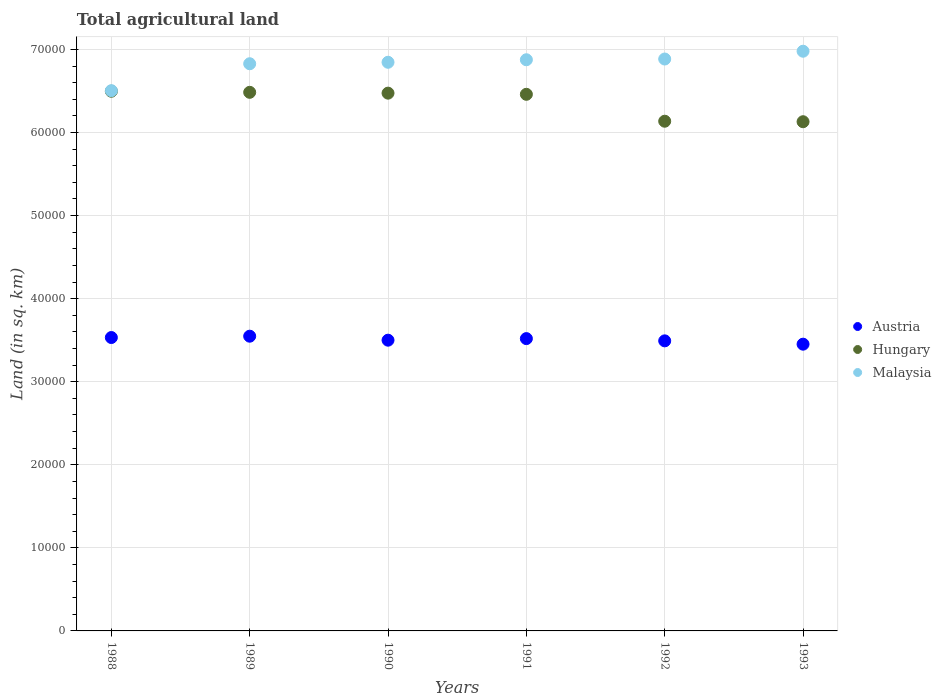How many different coloured dotlines are there?
Offer a very short reply. 3. What is the total agricultural land in Malaysia in 1992?
Offer a very short reply. 6.88e+04. Across all years, what is the maximum total agricultural land in Malaysia?
Offer a very short reply. 6.98e+04. Across all years, what is the minimum total agricultural land in Hungary?
Ensure brevity in your answer.  6.13e+04. In which year was the total agricultural land in Austria maximum?
Your answer should be very brief. 1989. In which year was the total agricultural land in Austria minimum?
Offer a terse response. 1993. What is the total total agricultural land in Malaysia in the graph?
Offer a terse response. 4.09e+05. What is the difference between the total agricultural land in Hungary in 1991 and that in 1992?
Give a very brief answer. 3240. What is the difference between the total agricultural land in Austria in 1989 and the total agricultural land in Malaysia in 1990?
Offer a very short reply. -3.30e+04. What is the average total agricultural land in Malaysia per year?
Ensure brevity in your answer.  6.82e+04. In the year 1989, what is the difference between the total agricultural land in Malaysia and total agricultural land in Hungary?
Give a very brief answer. 3440. In how many years, is the total agricultural land in Austria greater than 36000 sq.km?
Make the answer very short. 0. What is the ratio of the total agricultural land in Malaysia in 1990 to that in 1992?
Make the answer very short. 0.99. Is the total agricultural land in Hungary in 1989 less than that in 1991?
Provide a short and direct response. No. What is the difference between the highest and the second highest total agricultural land in Hungary?
Your answer should be compact. 130. What is the difference between the highest and the lowest total agricultural land in Malaysia?
Your answer should be very brief. 4748. In how many years, is the total agricultural land in Hungary greater than the average total agricultural land in Hungary taken over all years?
Your answer should be compact. 4. Is the sum of the total agricultural land in Austria in 1989 and 1992 greater than the maximum total agricultural land in Malaysia across all years?
Provide a succinct answer. Yes. Is it the case that in every year, the sum of the total agricultural land in Hungary and total agricultural land in Austria  is greater than the total agricultural land in Malaysia?
Your answer should be compact. Yes. Is the total agricultural land in Austria strictly greater than the total agricultural land in Hungary over the years?
Your response must be concise. No. Is the total agricultural land in Austria strictly less than the total agricultural land in Malaysia over the years?
Give a very brief answer. Yes. How many years are there in the graph?
Your answer should be very brief. 6. What is the difference between two consecutive major ticks on the Y-axis?
Offer a very short reply. 10000. Where does the legend appear in the graph?
Provide a succinct answer. Center right. What is the title of the graph?
Make the answer very short. Total agricultural land. What is the label or title of the X-axis?
Your response must be concise. Years. What is the label or title of the Y-axis?
Give a very brief answer. Land (in sq. km). What is the Land (in sq. km) of Austria in 1988?
Ensure brevity in your answer.  3.53e+04. What is the Land (in sq. km) in Hungary in 1988?
Make the answer very short. 6.50e+04. What is the Land (in sq. km) of Malaysia in 1988?
Make the answer very short. 6.50e+04. What is the Land (in sq. km) of Austria in 1989?
Your answer should be very brief. 3.55e+04. What is the Land (in sq. km) of Hungary in 1989?
Your answer should be very brief. 6.48e+04. What is the Land (in sq. km) in Malaysia in 1989?
Offer a terse response. 6.83e+04. What is the Land (in sq. km) in Austria in 1990?
Make the answer very short. 3.50e+04. What is the Land (in sq. km) of Hungary in 1990?
Offer a very short reply. 6.47e+04. What is the Land (in sq. km) of Malaysia in 1990?
Provide a short and direct response. 6.85e+04. What is the Land (in sq. km) of Austria in 1991?
Ensure brevity in your answer.  3.52e+04. What is the Land (in sq. km) in Hungary in 1991?
Your answer should be very brief. 6.46e+04. What is the Land (in sq. km) of Malaysia in 1991?
Give a very brief answer. 6.88e+04. What is the Land (in sq. km) of Austria in 1992?
Provide a succinct answer. 3.49e+04. What is the Land (in sq. km) of Hungary in 1992?
Give a very brief answer. 6.14e+04. What is the Land (in sq. km) in Malaysia in 1992?
Offer a terse response. 6.88e+04. What is the Land (in sq. km) of Austria in 1993?
Your answer should be compact. 3.45e+04. What is the Land (in sq. km) in Hungary in 1993?
Make the answer very short. 6.13e+04. What is the Land (in sq. km) in Malaysia in 1993?
Keep it short and to the point. 6.98e+04. Across all years, what is the maximum Land (in sq. km) in Austria?
Offer a very short reply. 3.55e+04. Across all years, what is the maximum Land (in sq. km) in Hungary?
Offer a very short reply. 6.50e+04. Across all years, what is the maximum Land (in sq. km) in Malaysia?
Your response must be concise. 6.98e+04. Across all years, what is the minimum Land (in sq. km) of Austria?
Your response must be concise. 3.45e+04. Across all years, what is the minimum Land (in sq. km) of Hungary?
Offer a terse response. 6.13e+04. Across all years, what is the minimum Land (in sq. km) in Malaysia?
Keep it short and to the point. 6.50e+04. What is the total Land (in sq. km) in Austria in the graph?
Provide a short and direct response. 2.10e+05. What is the total Land (in sq. km) in Hungary in the graph?
Keep it short and to the point. 3.82e+05. What is the total Land (in sq. km) of Malaysia in the graph?
Keep it short and to the point. 4.09e+05. What is the difference between the Land (in sq. km) in Austria in 1988 and that in 1989?
Your response must be concise. -160. What is the difference between the Land (in sq. km) of Hungary in 1988 and that in 1989?
Your answer should be compact. 130. What is the difference between the Land (in sq. km) in Malaysia in 1988 and that in 1989?
Your answer should be compact. -3241. What is the difference between the Land (in sq. km) in Austria in 1988 and that in 1990?
Offer a very short reply. 320. What is the difference between the Land (in sq. km) of Hungary in 1988 and that in 1990?
Offer a terse response. 230. What is the difference between the Land (in sq. km) in Malaysia in 1988 and that in 1990?
Provide a succinct answer. -3418. What is the difference between the Land (in sq. km) of Austria in 1988 and that in 1991?
Offer a terse response. 130. What is the difference between the Land (in sq. km) in Hungary in 1988 and that in 1991?
Keep it short and to the point. 370. What is the difference between the Land (in sq. km) in Malaysia in 1988 and that in 1991?
Offer a terse response. -3721. What is the difference between the Land (in sq. km) of Hungary in 1988 and that in 1992?
Make the answer very short. 3610. What is the difference between the Land (in sq. km) of Malaysia in 1988 and that in 1992?
Ensure brevity in your answer.  -3809. What is the difference between the Land (in sq. km) in Austria in 1988 and that in 1993?
Offer a very short reply. 800. What is the difference between the Land (in sq. km) of Hungary in 1988 and that in 1993?
Provide a short and direct response. 3670. What is the difference between the Land (in sq. km) of Malaysia in 1988 and that in 1993?
Your response must be concise. -4748. What is the difference between the Land (in sq. km) of Austria in 1989 and that in 1990?
Keep it short and to the point. 480. What is the difference between the Land (in sq. km) of Malaysia in 1989 and that in 1990?
Offer a terse response. -177. What is the difference between the Land (in sq. km) of Austria in 1989 and that in 1991?
Your response must be concise. 290. What is the difference between the Land (in sq. km) in Hungary in 1989 and that in 1991?
Give a very brief answer. 240. What is the difference between the Land (in sq. km) in Malaysia in 1989 and that in 1991?
Your answer should be compact. -480. What is the difference between the Land (in sq. km) of Austria in 1989 and that in 1992?
Provide a short and direct response. 560. What is the difference between the Land (in sq. km) in Hungary in 1989 and that in 1992?
Make the answer very short. 3480. What is the difference between the Land (in sq. km) of Malaysia in 1989 and that in 1992?
Your answer should be very brief. -568. What is the difference between the Land (in sq. km) of Austria in 1989 and that in 1993?
Keep it short and to the point. 960. What is the difference between the Land (in sq. km) of Hungary in 1989 and that in 1993?
Your answer should be compact. 3540. What is the difference between the Land (in sq. km) in Malaysia in 1989 and that in 1993?
Your response must be concise. -1507. What is the difference between the Land (in sq. km) of Austria in 1990 and that in 1991?
Offer a terse response. -190. What is the difference between the Land (in sq. km) of Hungary in 1990 and that in 1991?
Offer a terse response. 140. What is the difference between the Land (in sq. km) of Malaysia in 1990 and that in 1991?
Provide a short and direct response. -303. What is the difference between the Land (in sq. km) of Hungary in 1990 and that in 1992?
Your answer should be compact. 3380. What is the difference between the Land (in sq. km) in Malaysia in 1990 and that in 1992?
Keep it short and to the point. -391. What is the difference between the Land (in sq. km) in Austria in 1990 and that in 1993?
Your answer should be compact. 480. What is the difference between the Land (in sq. km) of Hungary in 1990 and that in 1993?
Give a very brief answer. 3440. What is the difference between the Land (in sq. km) in Malaysia in 1990 and that in 1993?
Provide a short and direct response. -1330. What is the difference between the Land (in sq. km) of Austria in 1991 and that in 1992?
Provide a succinct answer. 270. What is the difference between the Land (in sq. km) of Hungary in 1991 and that in 1992?
Your response must be concise. 3240. What is the difference between the Land (in sq. km) of Malaysia in 1991 and that in 1992?
Make the answer very short. -88. What is the difference between the Land (in sq. km) in Austria in 1991 and that in 1993?
Offer a very short reply. 670. What is the difference between the Land (in sq. km) of Hungary in 1991 and that in 1993?
Offer a very short reply. 3300. What is the difference between the Land (in sq. km) of Malaysia in 1991 and that in 1993?
Offer a very short reply. -1027. What is the difference between the Land (in sq. km) in Austria in 1992 and that in 1993?
Keep it short and to the point. 400. What is the difference between the Land (in sq. km) in Malaysia in 1992 and that in 1993?
Give a very brief answer. -939. What is the difference between the Land (in sq. km) of Austria in 1988 and the Land (in sq. km) of Hungary in 1989?
Ensure brevity in your answer.  -2.95e+04. What is the difference between the Land (in sq. km) of Austria in 1988 and the Land (in sq. km) of Malaysia in 1989?
Your answer should be compact. -3.30e+04. What is the difference between the Land (in sq. km) in Hungary in 1988 and the Land (in sq. km) in Malaysia in 1989?
Your answer should be compact. -3310. What is the difference between the Land (in sq. km) in Austria in 1988 and the Land (in sq. km) in Hungary in 1990?
Provide a short and direct response. -2.94e+04. What is the difference between the Land (in sq. km) of Austria in 1988 and the Land (in sq. km) of Malaysia in 1990?
Keep it short and to the point. -3.31e+04. What is the difference between the Land (in sq. km) of Hungary in 1988 and the Land (in sq. km) of Malaysia in 1990?
Keep it short and to the point. -3487. What is the difference between the Land (in sq. km) of Austria in 1988 and the Land (in sq. km) of Hungary in 1991?
Keep it short and to the point. -2.93e+04. What is the difference between the Land (in sq. km) in Austria in 1988 and the Land (in sq. km) in Malaysia in 1991?
Offer a terse response. -3.34e+04. What is the difference between the Land (in sq. km) in Hungary in 1988 and the Land (in sq. km) in Malaysia in 1991?
Offer a very short reply. -3790. What is the difference between the Land (in sq. km) of Austria in 1988 and the Land (in sq. km) of Hungary in 1992?
Provide a succinct answer. -2.60e+04. What is the difference between the Land (in sq. km) of Austria in 1988 and the Land (in sq. km) of Malaysia in 1992?
Make the answer very short. -3.35e+04. What is the difference between the Land (in sq. km) in Hungary in 1988 and the Land (in sq. km) in Malaysia in 1992?
Offer a very short reply. -3878. What is the difference between the Land (in sq. km) in Austria in 1988 and the Land (in sq. km) in Hungary in 1993?
Provide a short and direct response. -2.60e+04. What is the difference between the Land (in sq. km) of Austria in 1988 and the Land (in sq. km) of Malaysia in 1993?
Provide a short and direct response. -3.45e+04. What is the difference between the Land (in sq. km) of Hungary in 1988 and the Land (in sq. km) of Malaysia in 1993?
Keep it short and to the point. -4817. What is the difference between the Land (in sq. km) in Austria in 1989 and the Land (in sq. km) in Hungary in 1990?
Your answer should be compact. -2.93e+04. What is the difference between the Land (in sq. km) in Austria in 1989 and the Land (in sq. km) in Malaysia in 1990?
Keep it short and to the point. -3.30e+04. What is the difference between the Land (in sq. km) in Hungary in 1989 and the Land (in sq. km) in Malaysia in 1990?
Ensure brevity in your answer.  -3617. What is the difference between the Land (in sq. km) in Austria in 1989 and the Land (in sq. km) in Hungary in 1991?
Give a very brief answer. -2.91e+04. What is the difference between the Land (in sq. km) in Austria in 1989 and the Land (in sq. km) in Malaysia in 1991?
Ensure brevity in your answer.  -3.33e+04. What is the difference between the Land (in sq. km) of Hungary in 1989 and the Land (in sq. km) of Malaysia in 1991?
Offer a terse response. -3920. What is the difference between the Land (in sq. km) of Austria in 1989 and the Land (in sq. km) of Hungary in 1992?
Your answer should be compact. -2.59e+04. What is the difference between the Land (in sq. km) of Austria in 1989 and the Land (in sq. km) of Malaysia in 1992?
Give a very brief answer. -3.34e+04. What is the difference between the Land (in sq. km) in Hungary in 1989 and the Land (in sq. km) in Malaysia in 1992?
Keep it short and to the point. -4008. What is the difference between the Land (in sq. km) in Austria in 1989 and the Land (in sq. km) in Hungary in 1993?
Your answer should be very brief. -2.58e+04. What is the difference between the Land (in sq. km) of Austria in 1989 and the Land (in sq. km) of Malaysia in 1993?
Ensure brevity in your answer.  -3.43e+04. What is the difference between the Land (in sq. km) in Hungary in 1989 and the Land (in sq. km) in Malaysia in 1993?
Your answer should be very brief. -4947. What is the difference between the Land (in sq. km) of Austria in 1990 and the Land (in sq. km) of Hungary in 1991?
Your response must be concise. -2.96e+04. What is the difference between the Land (in sq. km) of Austria in 1990 and the Land (in sq. km) of Malaysia in 1991?
Your response must be concise. -3.38e+04. What is the difference between the Land (in sq. km) of Hungary in 1990 and the Land (in sq. km) of Malaysia in 1991?
Ensure brevity in your answer.  -4020. What is the difference between the Land (in sq. km) of Austria in 1990 and the Land (in sq. km) of Hungary in 1992?
Offer a terse response. -2.64e+04. What is the difference between the Land (in sq. km) of Austria in 1990 and the Land (in sq. km) of Malaysia in 1992?
Offer a terse response. -3.38e+04. What is the difference between the Land (in sq. km) of Hungary in 1990 and the Land (in sq. km) of Malaysia in 1992?
Give a very brief answer. -4108. What is the difference between the Land (in sq. km) in Austria in 1990 and the Land (in sq. km) in Hungary in 1993?
Your answer should be very brief. -2.63e+04. What is the difference between the Land (in sq. km) of Austria in 1990 and the Land (in sq. km) of Malaysia in 1993?
Offer a terse response. -3.48e+04. What is the difference between the Land (in sq. km) in Hungary in 1990 and the Land (in sq. km) in Malaysia in 1993?
Your answer should be very brief. -5047. What is the difference between the Land (in sq. km) in Austria in 1991 and the Land (in sq. km) in Hungary in 1992?
Your response must be concise. -2.62e+04. What is the difference between the Land (in sq. km) of Austria in 1991 and the Land (in sq. km) of Malaysia in 1992?
Your response must be concise. -3.37e+04. What is the difference between the Land (in sq. km) in Hungary in 1991 and the Land (in sq. km) in Malaysia in 1992?
Provide a short and direct response. -4248. What is the difference between the Land (in sq. km) of Austria in 1991 and the Land (in sq. km) of Hungary in 1993?
Provide a short and direct response. -2.61e+04. What is the difference between the Land (in sq. km) of Austria in 1991 and the Land (in sq. km) of Malaysia in 1993?
Offer a very short reply. -3.46e+04. What is the difference between the Land (in sq. km) in Hungary in 1991 and the Land (in sq. km) in Malaysia in 1993?
Make the answer very short. -5187. What is the difference between the Land (in sq. km) in Austria in 1992 and the Land (in sq. km) in Hungary in 1993?
Ensure brevity in your answer.  -2.64e+04. What is the difference between the Land (in sq. km) in Austria in 1992 and the Land (in sq. km) in Malaysia in 1993?
Provide a short and direct response. -3.49e+04. What is the difference between the Land (in sq. km) of Hungary in 1992 and the Land (in sq. km) of Malaysia in 1993?
Provide a short and direct response. -8427. What is the average Land (in sq. km) of Austria per year?
Provide a succinct answer. 3.51e+04. What is the average Land (in sq. km) of Hungary per year?
Make the answer very short. 6.36e+04. What is the average Land (in sq. km) in Malaysia per year?
Ensure brevity in your answer.  6.82e+04. In the year 1988, what is the difference between the Land (in sq. km) of Austria and Land (in sq. km) of Hungary?
Ensure brevity in your answer.  -2.96e+04. In the year 1988, what is the difference between the Land (in sq. km) in Austria and Land (in sq. km) in Malaysia?
Ensure brevity in your answer.  -2.97e+04. In the year 1988, what is the difference between the Land (in sq. km) of Hungary and Land (in sq. km) of Malaysia?
Your response must be concise. -69. In the year 1989, what is the difference between the Land (in sq. km) of Austria and Land (in sq. km) of Hungary?
Offer a very short reply. -2.94e+04. In the year 1989, what is the difference between the Land (in sq. km) of Austria and Land (in sq. km) of Malaysia?
Offer a very short reply. -3.28e+04. In the year 1989, what is the difference between the Land (in sq. km) in Hungary and Land (in sq. km) in Malaysia?
Give a very brief answer. -3440. In the year 1990, what is the difference between the Land (in sq. km) of Austria and Land (in sq. km) of Hungary?
Give a very brief answer. -2.97e+04. In the year 1990, what is the difference between the Land (in sq. km) of Austria and Land (in sq. km) of Malaysia?
Your answer should be compact. -3.35e+04. In the year 1990, what is the difference between the Land (in sq. km) in Hungary and Land (in sq. km) in Malaysia?
Your response must be concise. -3717. In the year 1991, what is the difference between the Land (in sq. km) in Austria and Land (in sq. km) in Hungary?
Offer a terse response. -2.94e+04. In the year 1991, what is the difference between the Land (in sq. km) in Austria and Land (in sq. km) in Malaysia?
Ensure brevity in your answer.  -3.36e+04. In the year 1991, what is the difference between the Land (in sq. km) in Hungary and Land (in sq. km) in Malaysia?
Your answer should be compact. -4160. In the year 1992, what is the difference between the Land (in sq. km) of Austria and Land (in sq. km) of Hungary?
Offer a very short reply. -2.64e+04. In the year 1992, what is the difference between the Land (in sq. km) in Austria and Land (in sq. km) in Malaysia?
Your answer should be very brief. -3.39e+04. In the year 1992, what is the difference between the Land (in sq. km) in Hungary and Land (in sq. km) in Malaysia?
Your answer should be very brief. -7488. In the year 1993, what is the difference between the Land (in sq. km) in Austria and Land (in sq. km) in Hungary?
Keep it short and to the point. -2.68e+04. In the year 1993, what is the difference between the Land (in sq. km) of Austria and Land (in sq. km) of Malaysia?
Your answer should be compact. -3.53e+04. In the year 1993, what is the difference between the Land (in sq. km) in Hungary and Land (in sq. km) in Malaysia?
Offer a terse response. -8487. What is the ratio of the Land (in sq. km) of Austria in 1988 to that in 1989?
Your answer should be very brief. 1. What is the ratio of the Land (in sq. km) of Malaysia in 1988 to that in 1989?
Your response must be concise. 0.95. What is the ratio of the Land (in sq. km) in Austria in 1988 to that in 1990?
Make the answer very short. 1.01. What is the ratio of the Land (in sq. km) of Malaysia in 1988 to that in 1990?
Offer a very short reply. 0.95. What is the ratio of the Land (in sq. km) of Austria in 1988 to that in 1991?
Keep it short and to the point. 1. What is the ratio of the Land (in sq. km) in Malaysia in 1988 to that in 1991?
Provide a short and direct response. 0.95. What is the ratio of the Land (in sq. km) of Austria in 1988 to that in 1992?
Provide a succinct answer. 1.01. What is the ratio of the Land (in sq. km) in Hungary in 1988 to that in 1992?
Offer a terse response. 1.06. What is the ratio of the Land (in sq. km) in Malaysia in 1988 to that in 1992?
Your response must be concise. 0.94. What is the ratio of the Land (in sq. km) in Austria in 1988 to that in 1993?
Your answer should be very brief. 1.02. What is the ratio of the Land (in sq. km) of Hungary in 1988 to that in 1993?
Your response must be concise. 1.06. What is the ratio of the Land (in sq. km) of Malaysia in 1988 to that in 1993?
Provide a succinct answer. 0.93. What is the ratio of the Land (in sq. km) in Austria in 1989 to that in 1990?
Your answer should be compact. 1.01. What is the ratio of the Land (in sq. km) of Hungary in 1989 to that in 1990?
Offer a terse response. 1. What is the ratio of the Land (in sq. km) of Malaysia in 1989 to that in 1990?
Provide a short and direct response. 1. What is the ratio of the Land (in sq. km) in Austria in 1989 to that in 1991?
Your answer should be very brief. 1.01. What is the ratio of the Land (in sq. km) of Malaysia in 1989 to that in 1991?
Keep it short and to the point. 0.99. What is the ratio of the Land (in sq. km) in Austria in 1989 to that in 1992?
Keep it short and to the point. 1.02. What is the ratio of the Land (in sq. km) in Hungary in 1989 to that in 1992?
Your answer should be very brief. 1.06. What is the ratio of the Land (in sq. km) in Austria in 1989 to that in 1993?
Make the answer very short. 1.03. What is the ratio of the Land (in sq. km) of Hungary in 1989 to that in 1993?
Provide a succinct answer. 1.06. What is the ratio of the Land (in sq. km) in Malaysia in 1989 to that in 1993?
Make the answer very short. 0.98. What is the ratio of the Land (in sq. km) of Austria in 1990 to that in 1991?
Give a very brief answer. 0.99. What is the ratio of the Land (in sq. km) in Malaysia in 1990 to that in 1991?
Offer a very short reply. 1. What is the ratio of the Land (in sq. km) of Austria in 1990 to that in 1992?
Your answer should be very brief. 1. What is the ratio of the Land (in sq. km) of Hungary in 1990 to that in 1992?
Make the answer very short. 1.06. What is the ratio of the Land (in sq. km) of Malaysia in 1990 to that in 1992?
Offer a very short reply. 0.99. What is the ratio of the Land (in sq. km) in Austria in 1990 to that in 1993?
Your answer should be compact. 1.01. What is the ratio of the Land (in sq. km) of Hungary in 1990 to that in 1993?
Make the answer very short. 1.06. What is the ratio of the Land (in sq. km) in Malaysia in 1990 to that in 1993?
Make the answer very short. 0.98. What is the ratio of the Land (in sq. km) of Austria in 1991 to that in 1992?
Your answer should be very brief. 1.01. What is the ratio of the Land (in sq. km) of Hungary in 1991 to that in 1992?
Offer a terse response. 1.05. What is the ratio of the Land (in sq. km) in Malaysia in 1991 to that in 1992?
Offer a very short reply. 1. What is the ratio of the Land (in sq. km) of Austria in 1991 to that in 1993?
Your answer should be compact. 1.02. What is the ratio of the Land (in sq. km) in Hungary in 1991 to that in 1993?
Keep it short and to the point. 1.05. What is the ratio of the Land (in sq. km) of Malaysia in 1991 to that in 1993?
Provide a short and direct response. 0.99. What is the ratio of the Land (in sq. km) in Austria in 1992 to that in 1993?
Your response must be concise. 1.01. What is the ratio of the Land (in sq. km) of Malaysia in 1992 to that in 1993?
Make the answer very short. 0.99. What is the difference between the highest and the second highest Land (in sq. km) in Austria?
Your answer should be compact. 160. What is the difference between the highest and the second highest Land (in sq. km) of Hungary?
Keep it short and to the point. 130. What is the difference between the highest and the second highest Land (in sq. km) of Malaysia?
Offer a very short reply. 939. What is the difference between the highest and the lowest Land (in sq. km) of Austria?
Your answer should be compact. 960. What is the difference between the highest and the lowest Land (in sq. km) in Hungary?
Make the answer very short. 3670. What is the difference between the highest and the lowest Land (in sq. km) in Malaysia?
Keep it short and to the point. 4748. 